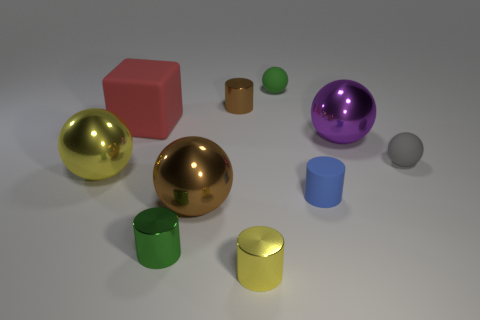How many objects are small yellow metallic cylinders in front of the tiny gray ball or large things to the right of the small rubber cylinder?
Offer a terse response. 2. What number of large purple metal objects are behind the brown shiny thing that is in front of the purple shiny sphere?
Ensure brevity in your answer.  1. There is a tiny rubber thing behind the small gray rubber thing; is it the same shape as the object left of the red matte block?
Ensure brevity in your answer.  Yes. Is there a small purple cylinder that has the same material as the blue cylinder?
Keep it short and to the point. No. What number of metal objects are gray objects or yellow blocks?
Offer a terse response. 0. The small green thing that is to the right of the small green thing that is in front of the tiny blue cylinder is what shape?
Ensure brevity in your answer.  Sphere. Are there fewer red matte blocks to the left of the red matte thing than tiny green objects?
Offer a very short reply. Yes. What is the shape of the large yellow metallic object?
Make the answer very short. Sphere. There is a brown thing in front of the blue rubber cylinder; what size is it?
Your answer should be very brief. Large. What color is the rubber cube that is the same size as the purple sphere?
Provide a short and direct response. Red. 